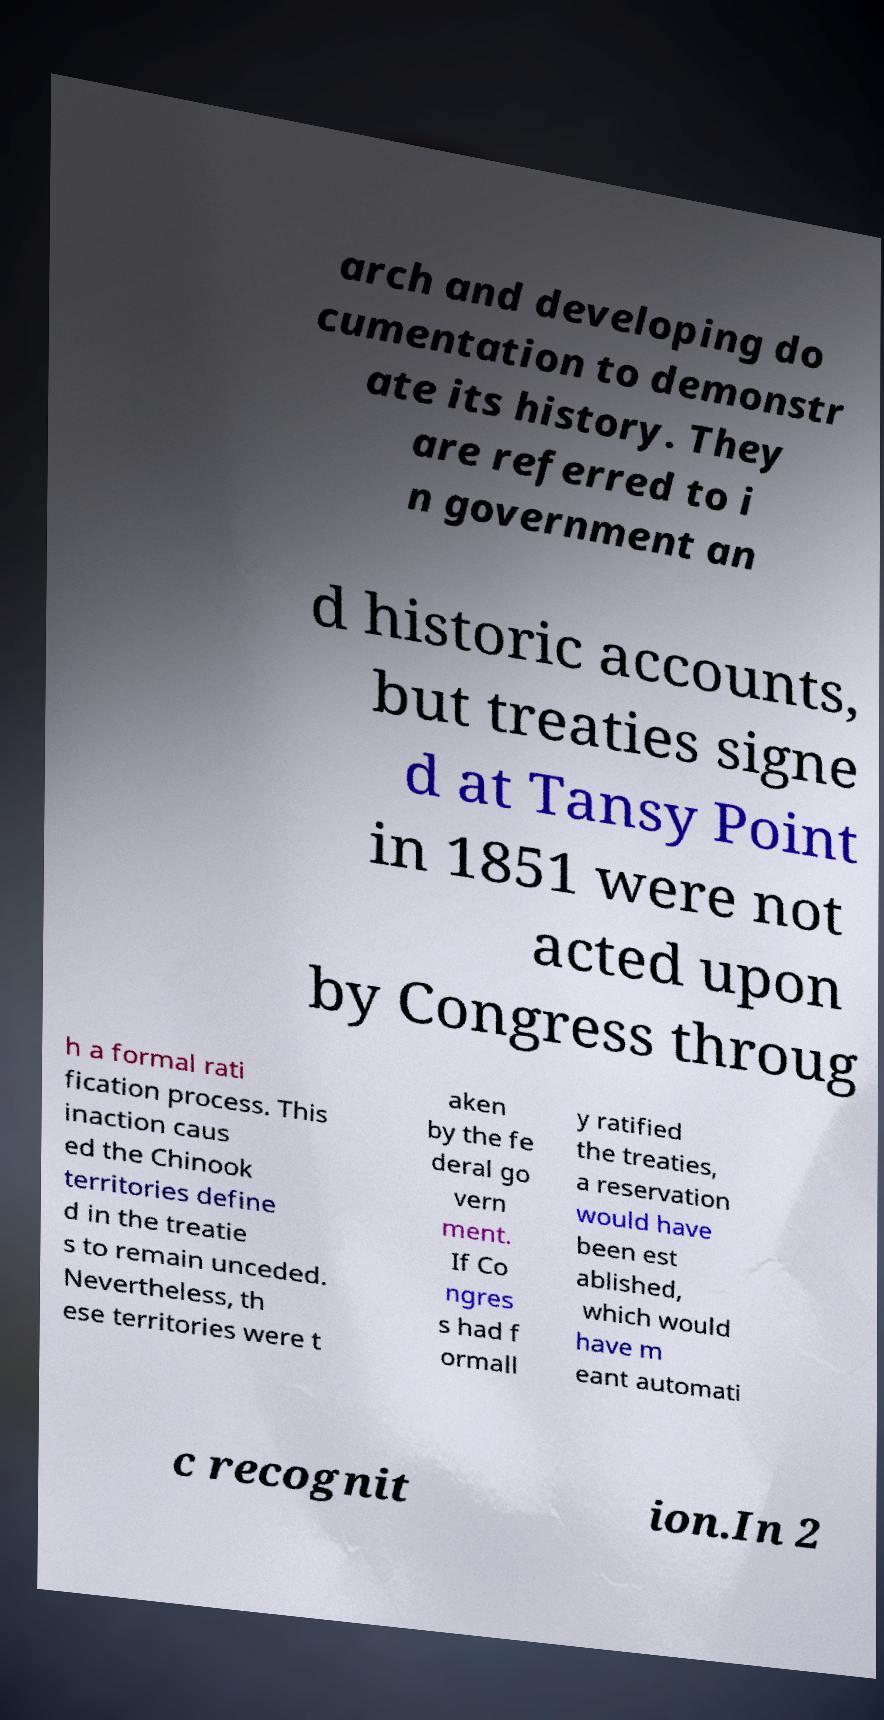For documentation purposes, I need the text within this image transcribed. Could you provide that? arch and developing do cumentation to demonstr ate its history. They are referred to i n government an d historic accounts, but treaties signe d at Tansy Point in 1851 were not acted upon by Congress throug h a formal rati fication process. This inaction caus ed the Chinook territories define d in the treatie s to remain unceded. Nevertheless, th ese territories were t aken by the fe deral go vern ment. If Co ngres s had f ormall y ratified the treaties, a reservation would have been est ablished, which would have m eant automati c recognit ion.In 2 